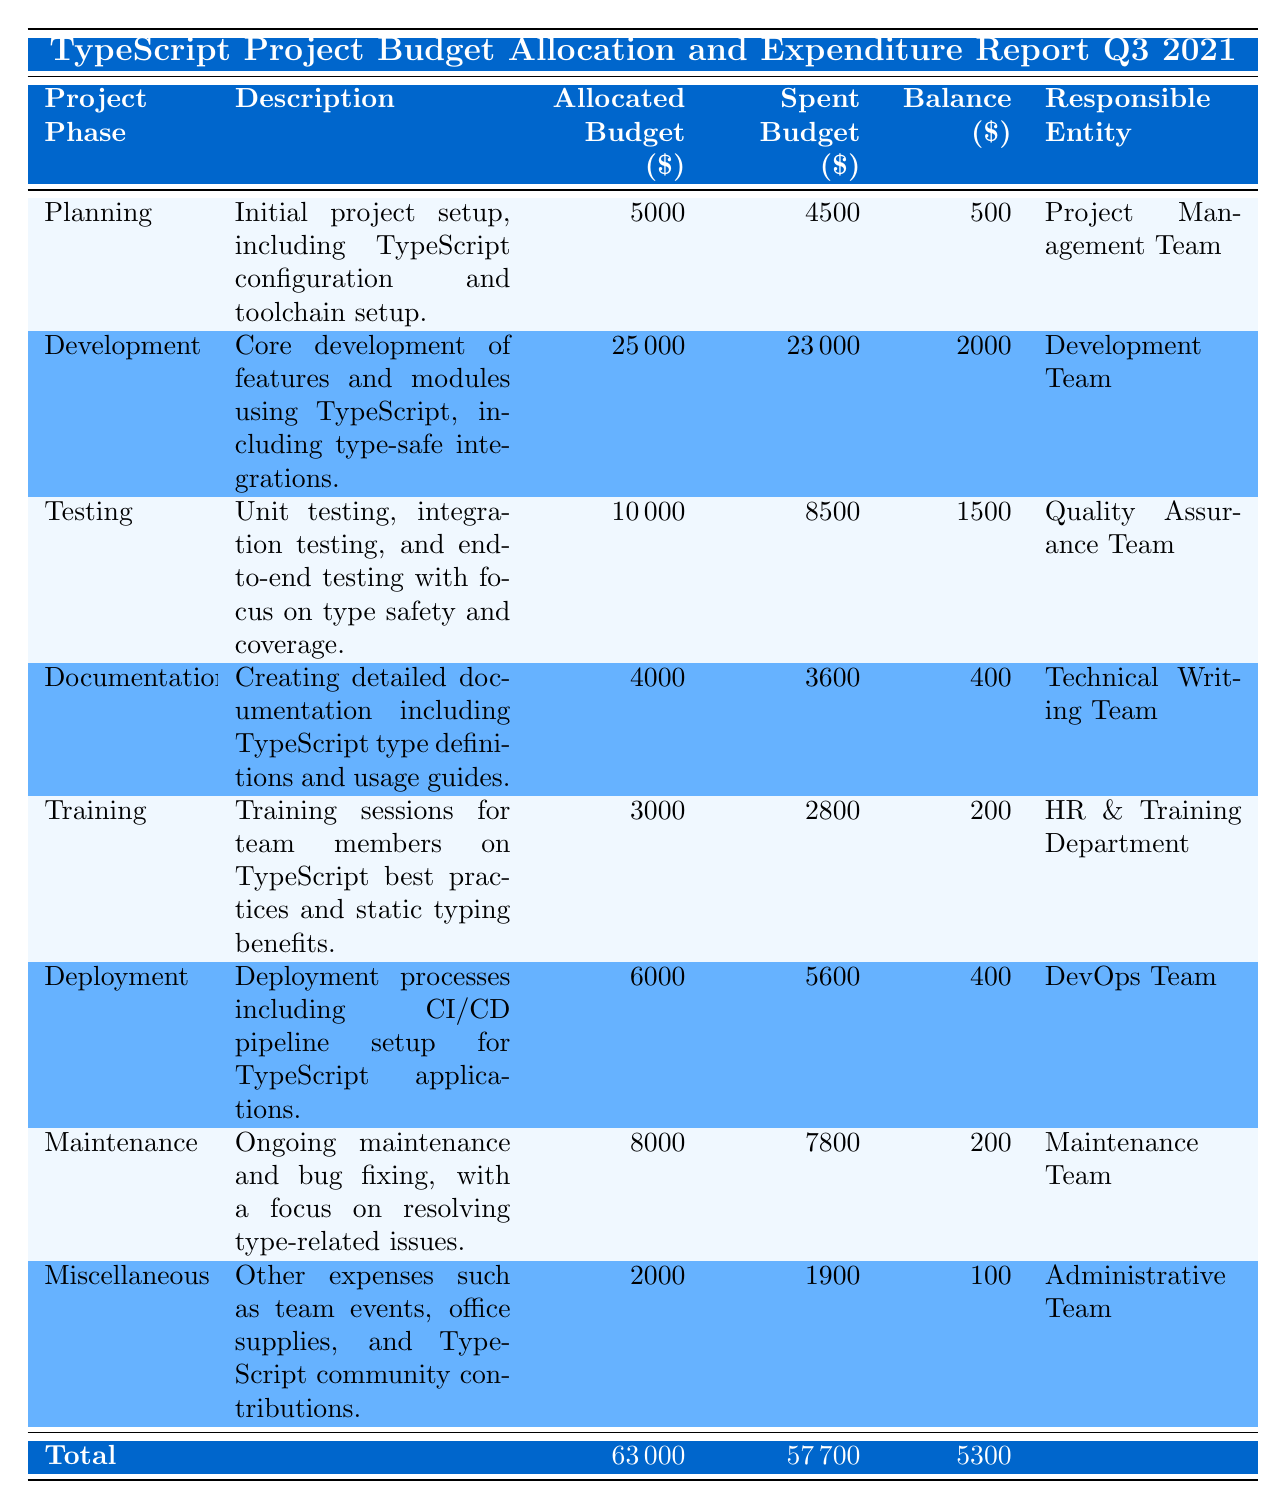What is the total allocated budget for the TypeScript project? The total allocated budget is found by summing up the allocated budget across all project phases: 5000 + 25000 + 10000 + 4000 + 3000 + 6000 + 8000 + 2000 = 63000
Answer: 63000 How much of the allocated budget has been spent in the Testing phase? The spent budget in the Testing phase is directly stated in the table and is 8500
Answer: 8500 Which project phase has the highest allocated budget? The Development phase has the highest allocated budget of 25000, which can be seen by comparing all allocated budget values in the table.
Answer: 25000 Is the spent budget in the Maintenance phase greater than the balance? To find out, we check the spent budget in the Maintenance phase, which is 7800, and the balance, which is 200. Since 7800 is greater than 200, the statement is true.
Answer: Yes What is the combined balance of the Planning and Documentation phases? We can find the combined balance by adding the balances of both phases: Planning has a balance of 500 and Documentation has a balance of 400. Therefore, 500 + 400 = 900.
Answer: 900 What percentage of the Development phase's allocated budget has been spent? The percentage spent is calculated by taking the spent budget (23000) divided by the allocated budget (25000) and multiplying by 100. Thus, (23000 / 25000) * 100 = 92%.
Answer: 92% What is the difference between the allocated and spent budgets in the Training phase? In the Training phase, the allocated budget is 3000 and the spent budget is 2800. The difference is calculated as 3000 - 2800 = 200.
Answer: 200 Which entity is responsible for the core development phase? The responsible entity for the Development phase, as noted in the table, is the Development Team.
Answer: Development Team How much budget was allocated for the Miscellaneous phase compared to the total allocated budget? The allocated budget for Miscellaneous is 2000. The total allocated budget is 63000. Thus, the proportion is 2000 out of 63000, which shows Miscellaneous takes a smaller share. The exact number is 2000 / 63000 = approximately 3.17%.
Answer: 3.17% 